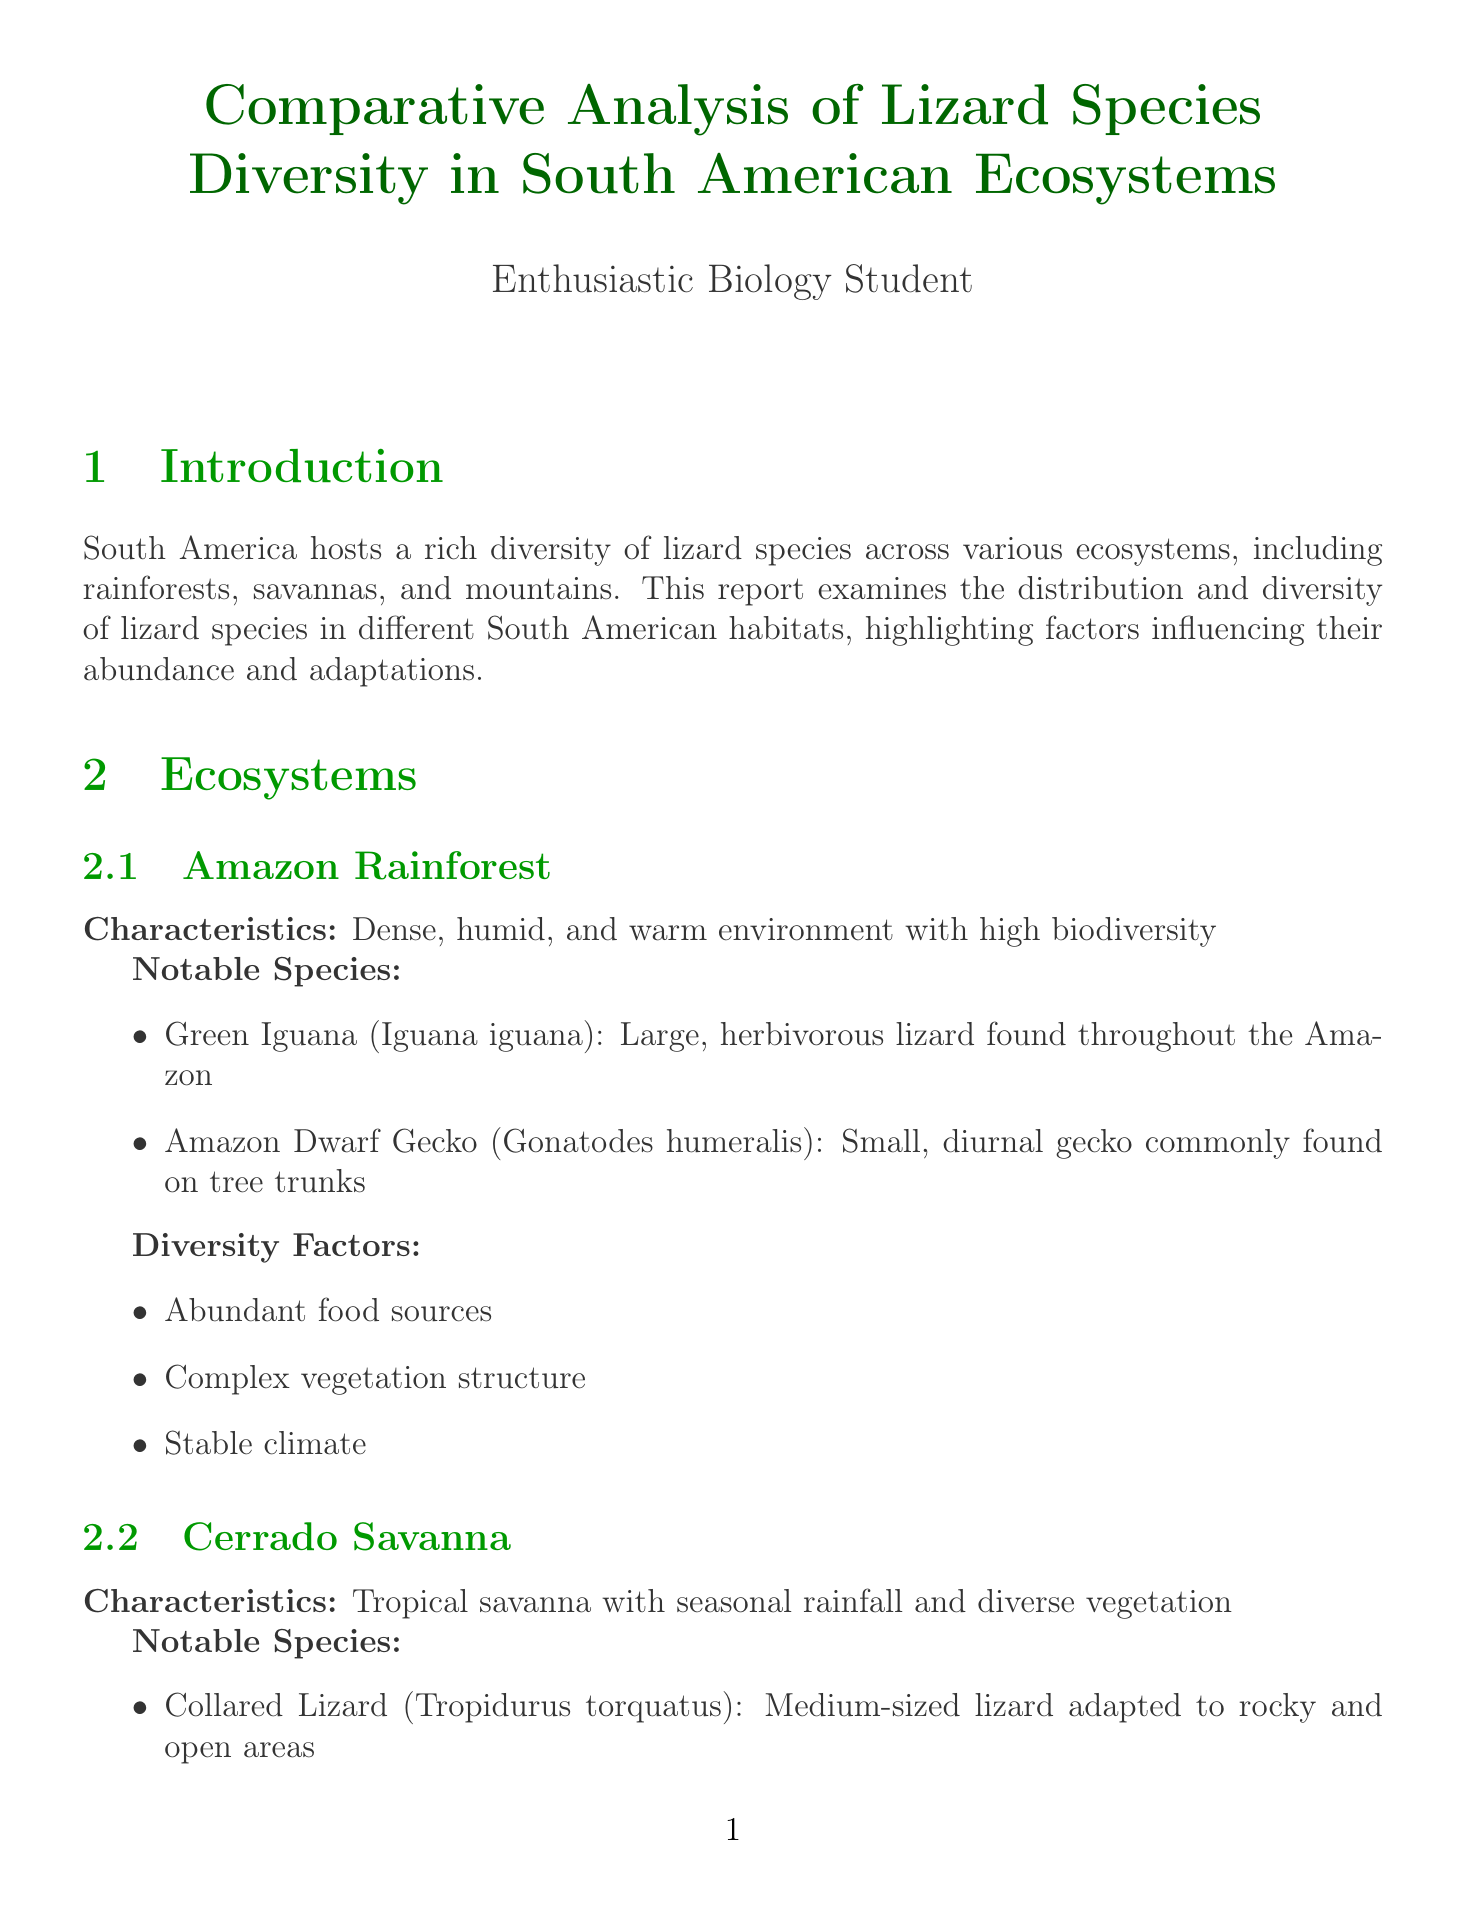What key factor contributes to the highest lizard diversity in the Amazon Rainforest? The Amazon Rainforest exhibits the highest diversity due to its stable climate and abundant resources.
Answer: Stable climate and abundant resources Which lizard species is notable for being an herbivorous lizard found throughout the Amazon? The notable herbivorous lizard in the Amazon is the Green Iguana.
Answer: Green Iguana What is the primary ecological role of lizards in the rainforest ecosystem? In rainforests, lizards play an important role as seed dispersers and prey for numerous predators.
Answer: Seed dispersers and prey for numerous predators What habitat adaptations are significant for lizards in the Cerrado Savanna? Lizards in the Cerrado Savanna have adaptations such as burrowing abilities and drought resistance.
Answer: Burrowing abilities, drought resistance Which South American ecosystem is characterized by extreme temperature fluctuations? The high-altitude Andes Mountains exhibit extreme temperature fluctuations.
Answer: Andes Mountains What are two major threats to lizard populations identified in the document? Major threats include habitat loss due to deforestation and climate change.
Answer: Habitat loss due to deforestation, climate change How does the species richness in mountains compare to that in rainforests and savannas? Mountains have lower overall diversity but high endemism compared to rainforests and savannas.
Answer: Lower overall diversity but high endemism What is identified as a conservation effort for lizards across all ecosystems? Establishment of protected areas in all ecosystems is a key conservation effort.
Answer: Establishment of protected areas Who are the authors of the reference titled "Lizards of South America: Diversity, Distribution, and Evolution"? The authors of the reference are Carvalho et al.
Answer: Carvalho et al 